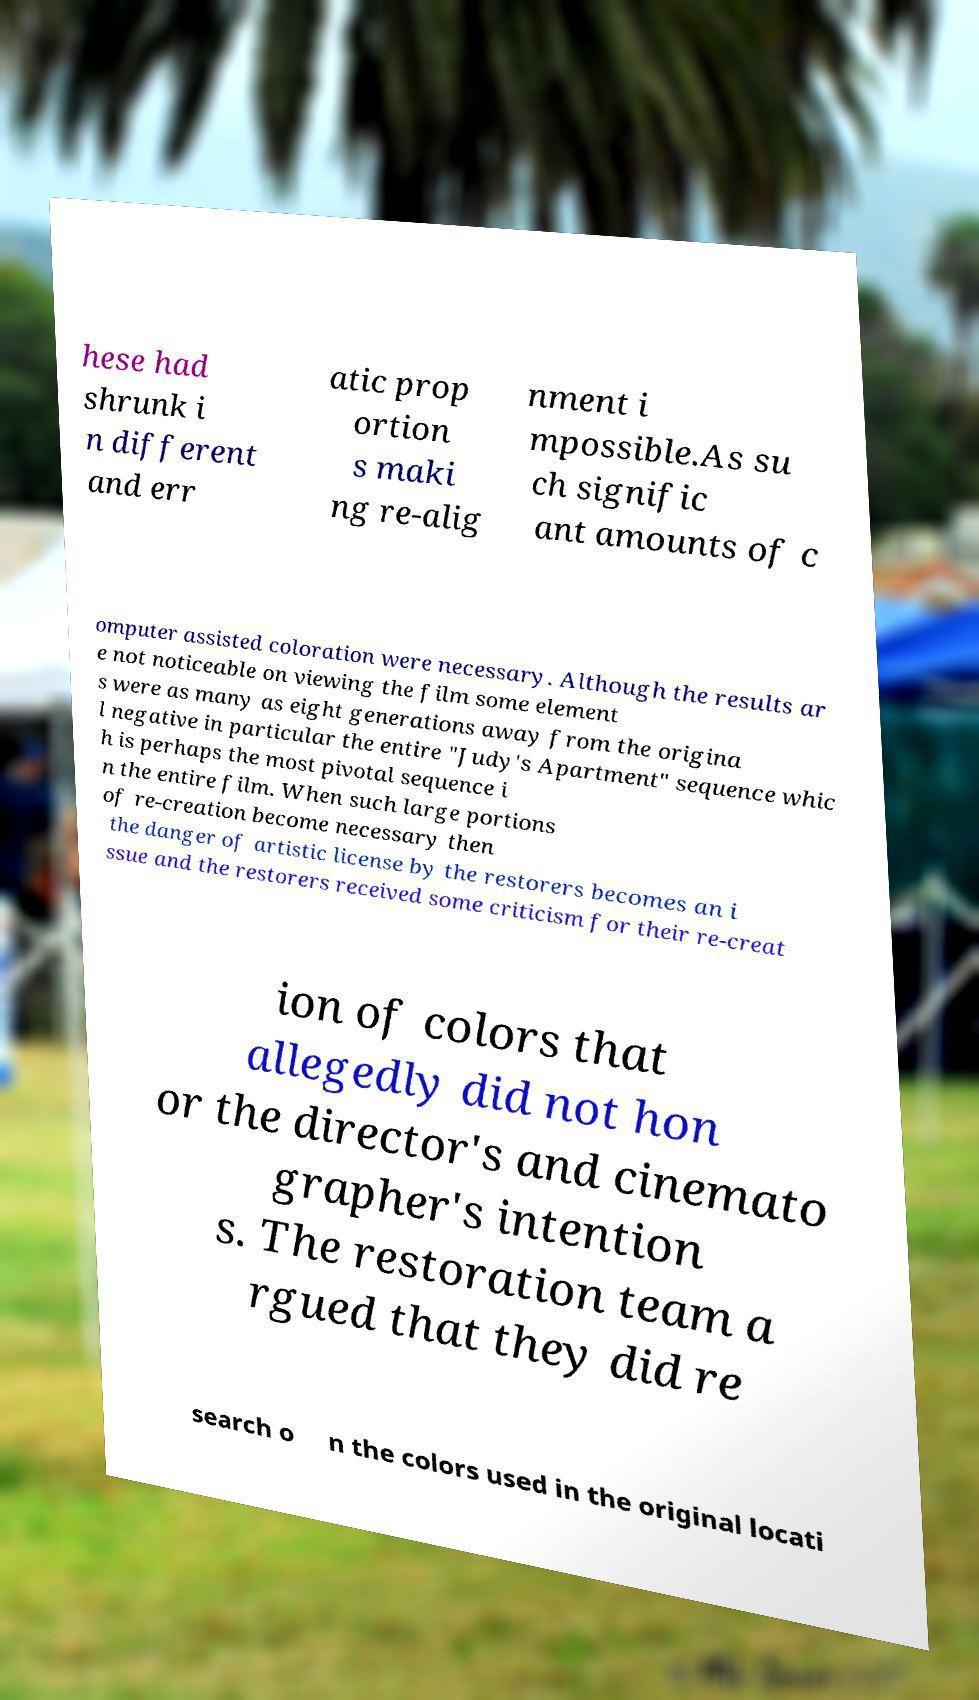Can you read and provide the text displayed in the image?This photo seems to have some interesting text. Can you extract and type it out for me? hese had shrunk i n different and err atic prop ortion s maki ng re-alig nment i mpossible.As su ch signific ant amounts of c omputer assisted coloration were necessary. Although the results ar e not noticeable on viewing the film some element s were as many as eight generations away from the origina l negative in particular the entire "Judy's Apartment" sequence whic h is perhaps the most pivotal sequence i n the entire film. When such large portions of re-creation become necessary then the danger of artistic license by the restorers becomes an i ssue and the restorers received some criticism for their re-creat ion of colors that allegedly did not hon or the director's and cinemato grapher's intention s. The restoration team a rgued that they did re search o n the colors used in the original locati 